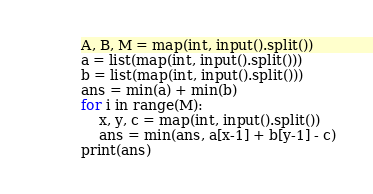<code> <loc_0><loc_0><loc_500><loc_500><_Python_>A, B, M = map(int, input().split())
a = list(map(int, input().split()))
b = list(map(int, input().split()))
ans = min(a) + min(b)
for i in range(M):
    x, y, c = map(int, input().split())
    ans = min(ans, a[x-1] + b[y-1] - c)
print(ans)</code> 